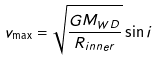<formula> <loc_0><loc_0><loc_500><loc_500>v _ { \max } = \sqrt { \frac { G M _ { W D } } { R _ { i n n e r } } } \sin i</formula> 